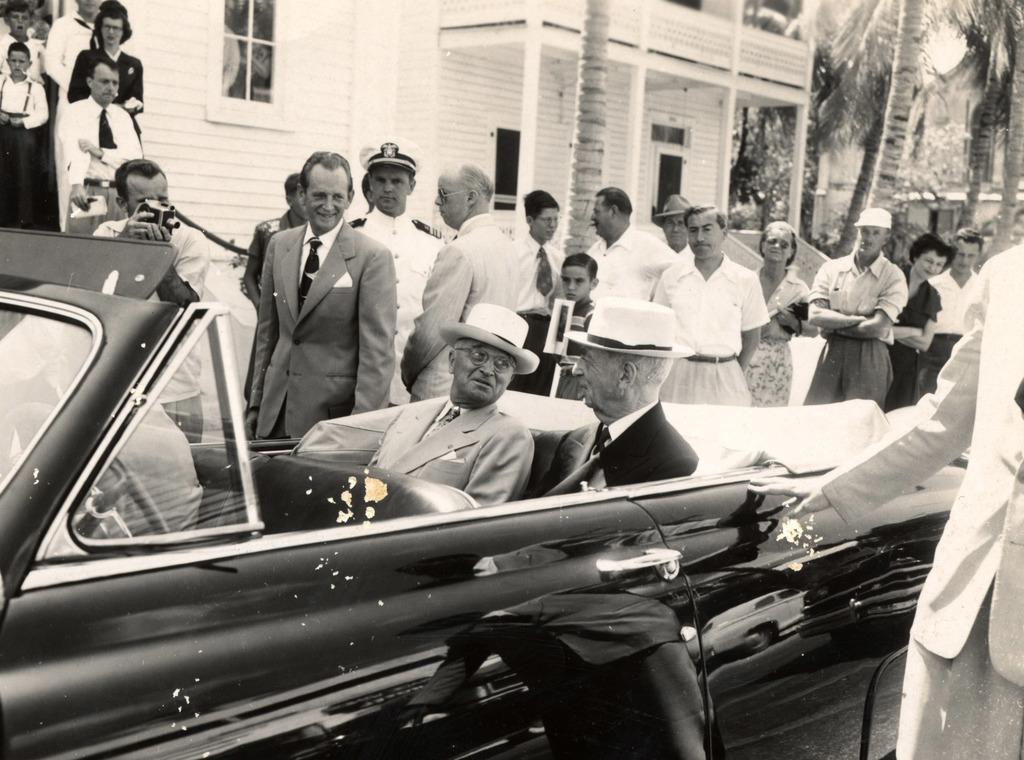Could you give a brief overview of what you see in this image? In this picture there are few people standing. There are two men in the car. There is a man holding a camera. There is a building. There are few trees at the background. 